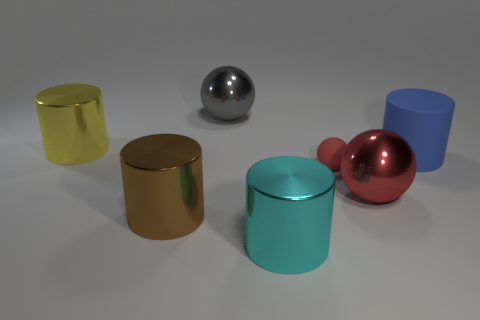How many objects are there and what are their colors? There are five objects in the image, each with its own distinct color. Starting from the left, there's a yellow cylinder, a silver sphere, a gold cylinder, a cyan cylinder, and a red sphere. 